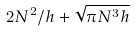<formula> <loc_0><loc_0><loc_500><loc_500>2 N ^ { 2 } / h + \sqrt { \pi N ^ { 3 } h }</formula> 